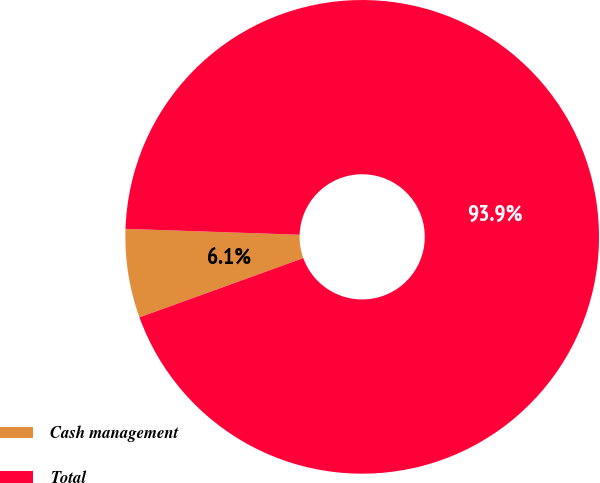Convert chart. <chart><loc_0><loc_0><loc_500><loc_500><pie_chart><fcel>Cash management<fcel>Total<nl><fcel>6.06%<fcel>93.94%<nl></chart> 